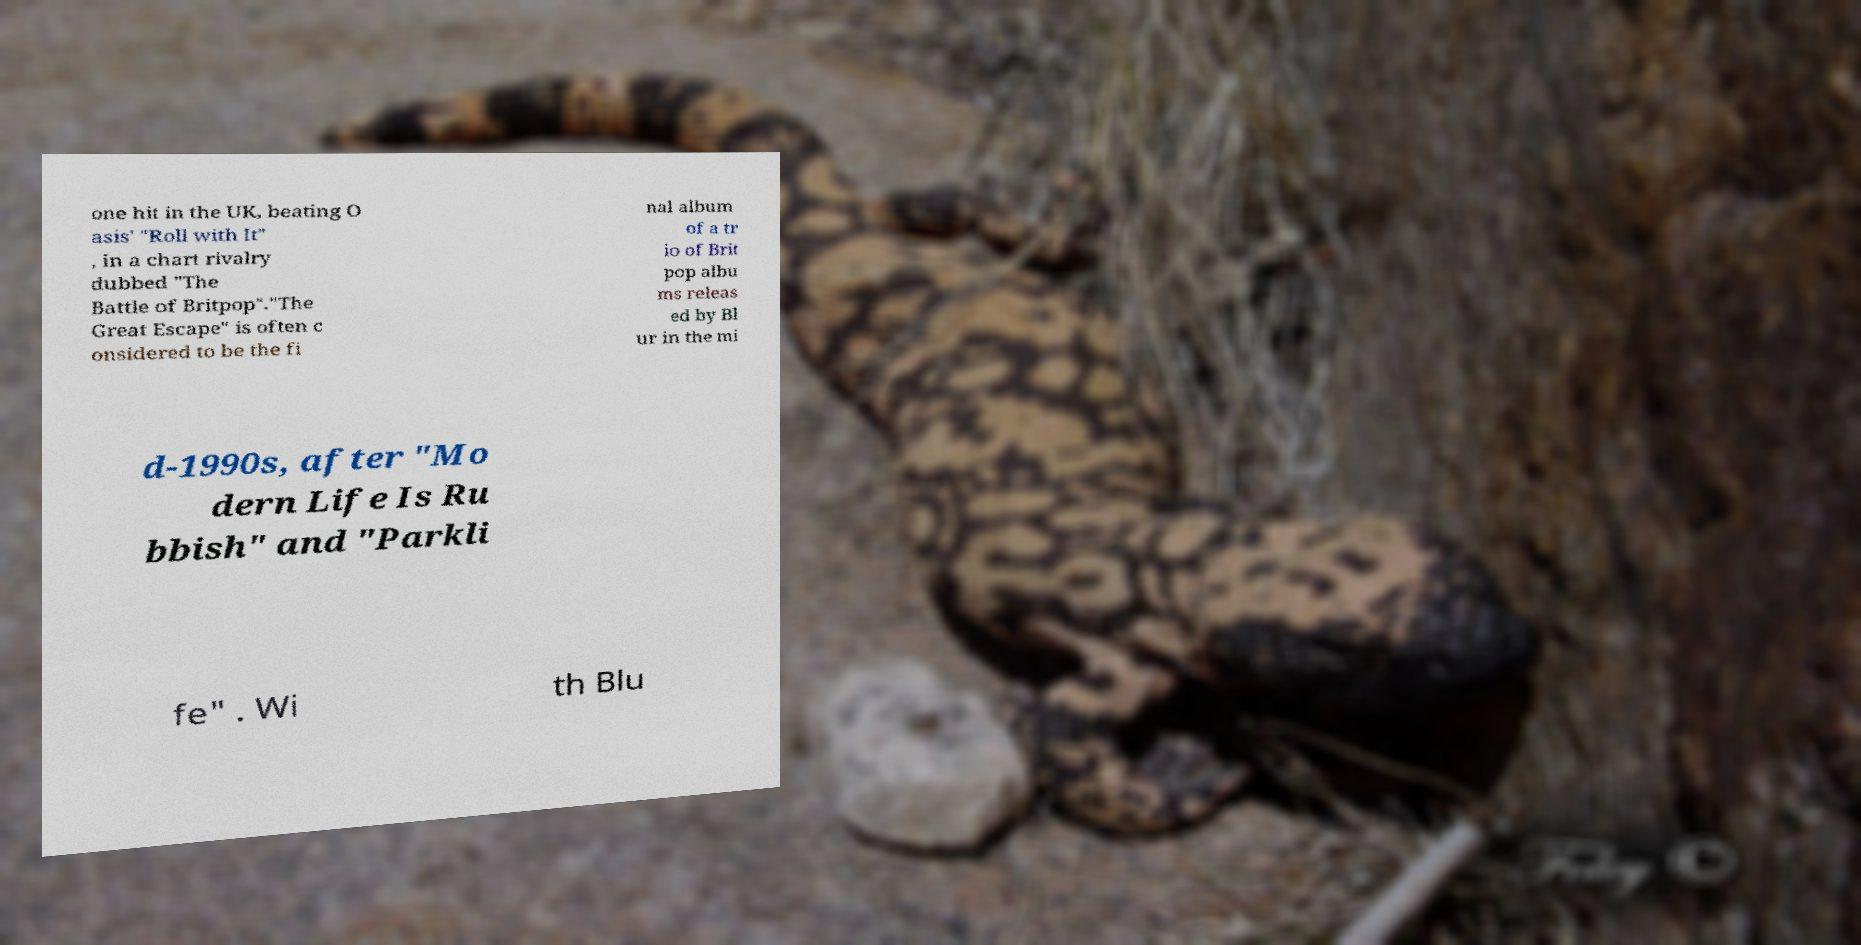There's text embedded in this image that I need extracted. Can you transcribe it verbatim? one hit in the UK, beating O asis' "Roll with It" , in a chart rivalry dubbed "The Battle of Britpop"."The Great Escape" is often c onsidered to be the fi nal album of a tr io of Brit pop albu ms releas ed by Bl ur in the mi d-1990s, after "Mo dern Life Is Ru bbish" and "Parkli fe" . Wi th Blu 